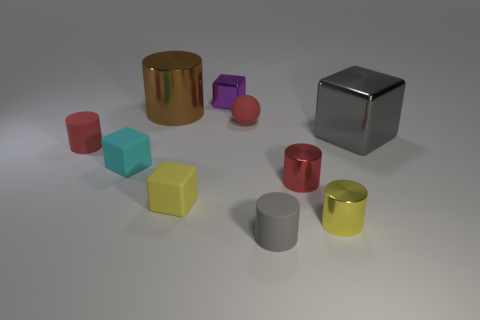How many tiny brown balls are there?
Make the answer very short. 0. Is the number of blocks in front of the gray metal cube less than the number of gray matte things in front of the gray rubber cylinder?
Offer a very short reply. No. Are there fewer small rubber cylinders that are to the right of the gray rubber thing than red metal objects?
Offer a terse response. Yes. The small red thing that is behind the cube that is right of the matte cylinder on the right side of the cyan cube is made of what material?
Offer a terse response. Rubber. How many things are metallic objects that are on the right side of the small yellow shiny cylinder or rubber things in front of the red metal cylinder?
Your answer should be compact. 3. There is a gray thing that is the same shape as the big brown metal object; what is its material?
Ensure brevity in your answer.  Rubber. How many metallic things are either cyan cylinders or big cylinders?
Make the answer very short. 1. What is the shape of the red object that is the same material as the big gray block?
Your response must be concise. Cylinder. What number of red things have the same shape as the yellow shiny object?
Ensure brevity in your answer.  2. Does the red rubber object left of the purple object have the same shape as the big thing that is right of the tiny red metallic thing?
Make the answer very short. No. 